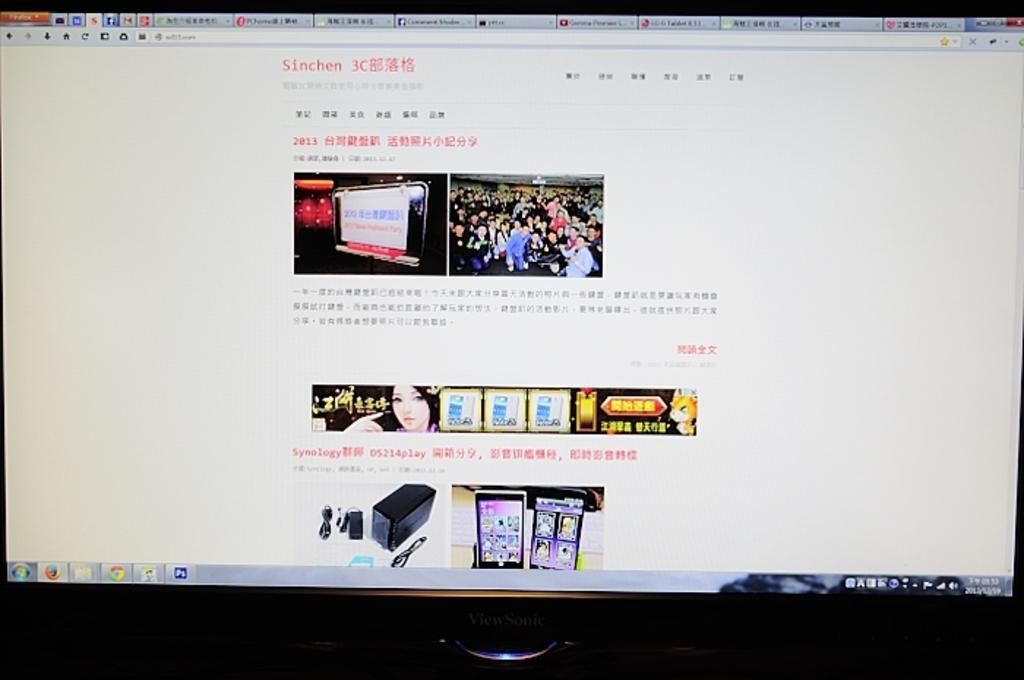What is displayed on the screen of the monitor in the image? There is text and images visible on the screen of the monitor. Can you describe the text or images in more detail? Unfortunately, the specific content of the text and images cannot be determined from the image alone. What type of school is depicted in the image? There is no school present in the image; it only features a monitor with text and images on its screen. 